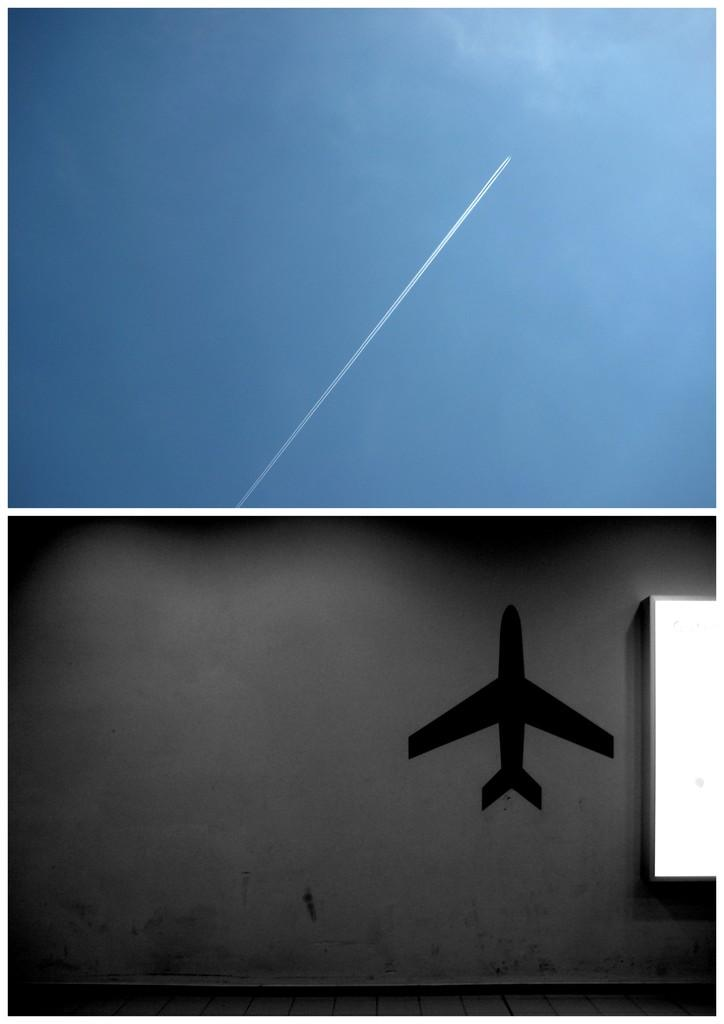What type of image is being described? The image is a collage. What can be seen in the sky at the top of the image? There is smoke visible in the sky at the top of the image. What is depicted at the bottom of the image? There is a shadow of an airplane at the bottom of the image. What language is being spoken by the pail in the image? There is no pail present in the image, and therefore no language being spoken by it. 